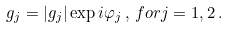<formula> <loc_0><loc_0><loc_500><loc_500>g _ { j } = | g _ { j } | \exp i \varphi _ { j } \, , \, f o r j = 1 , 2 \, .</formula> 